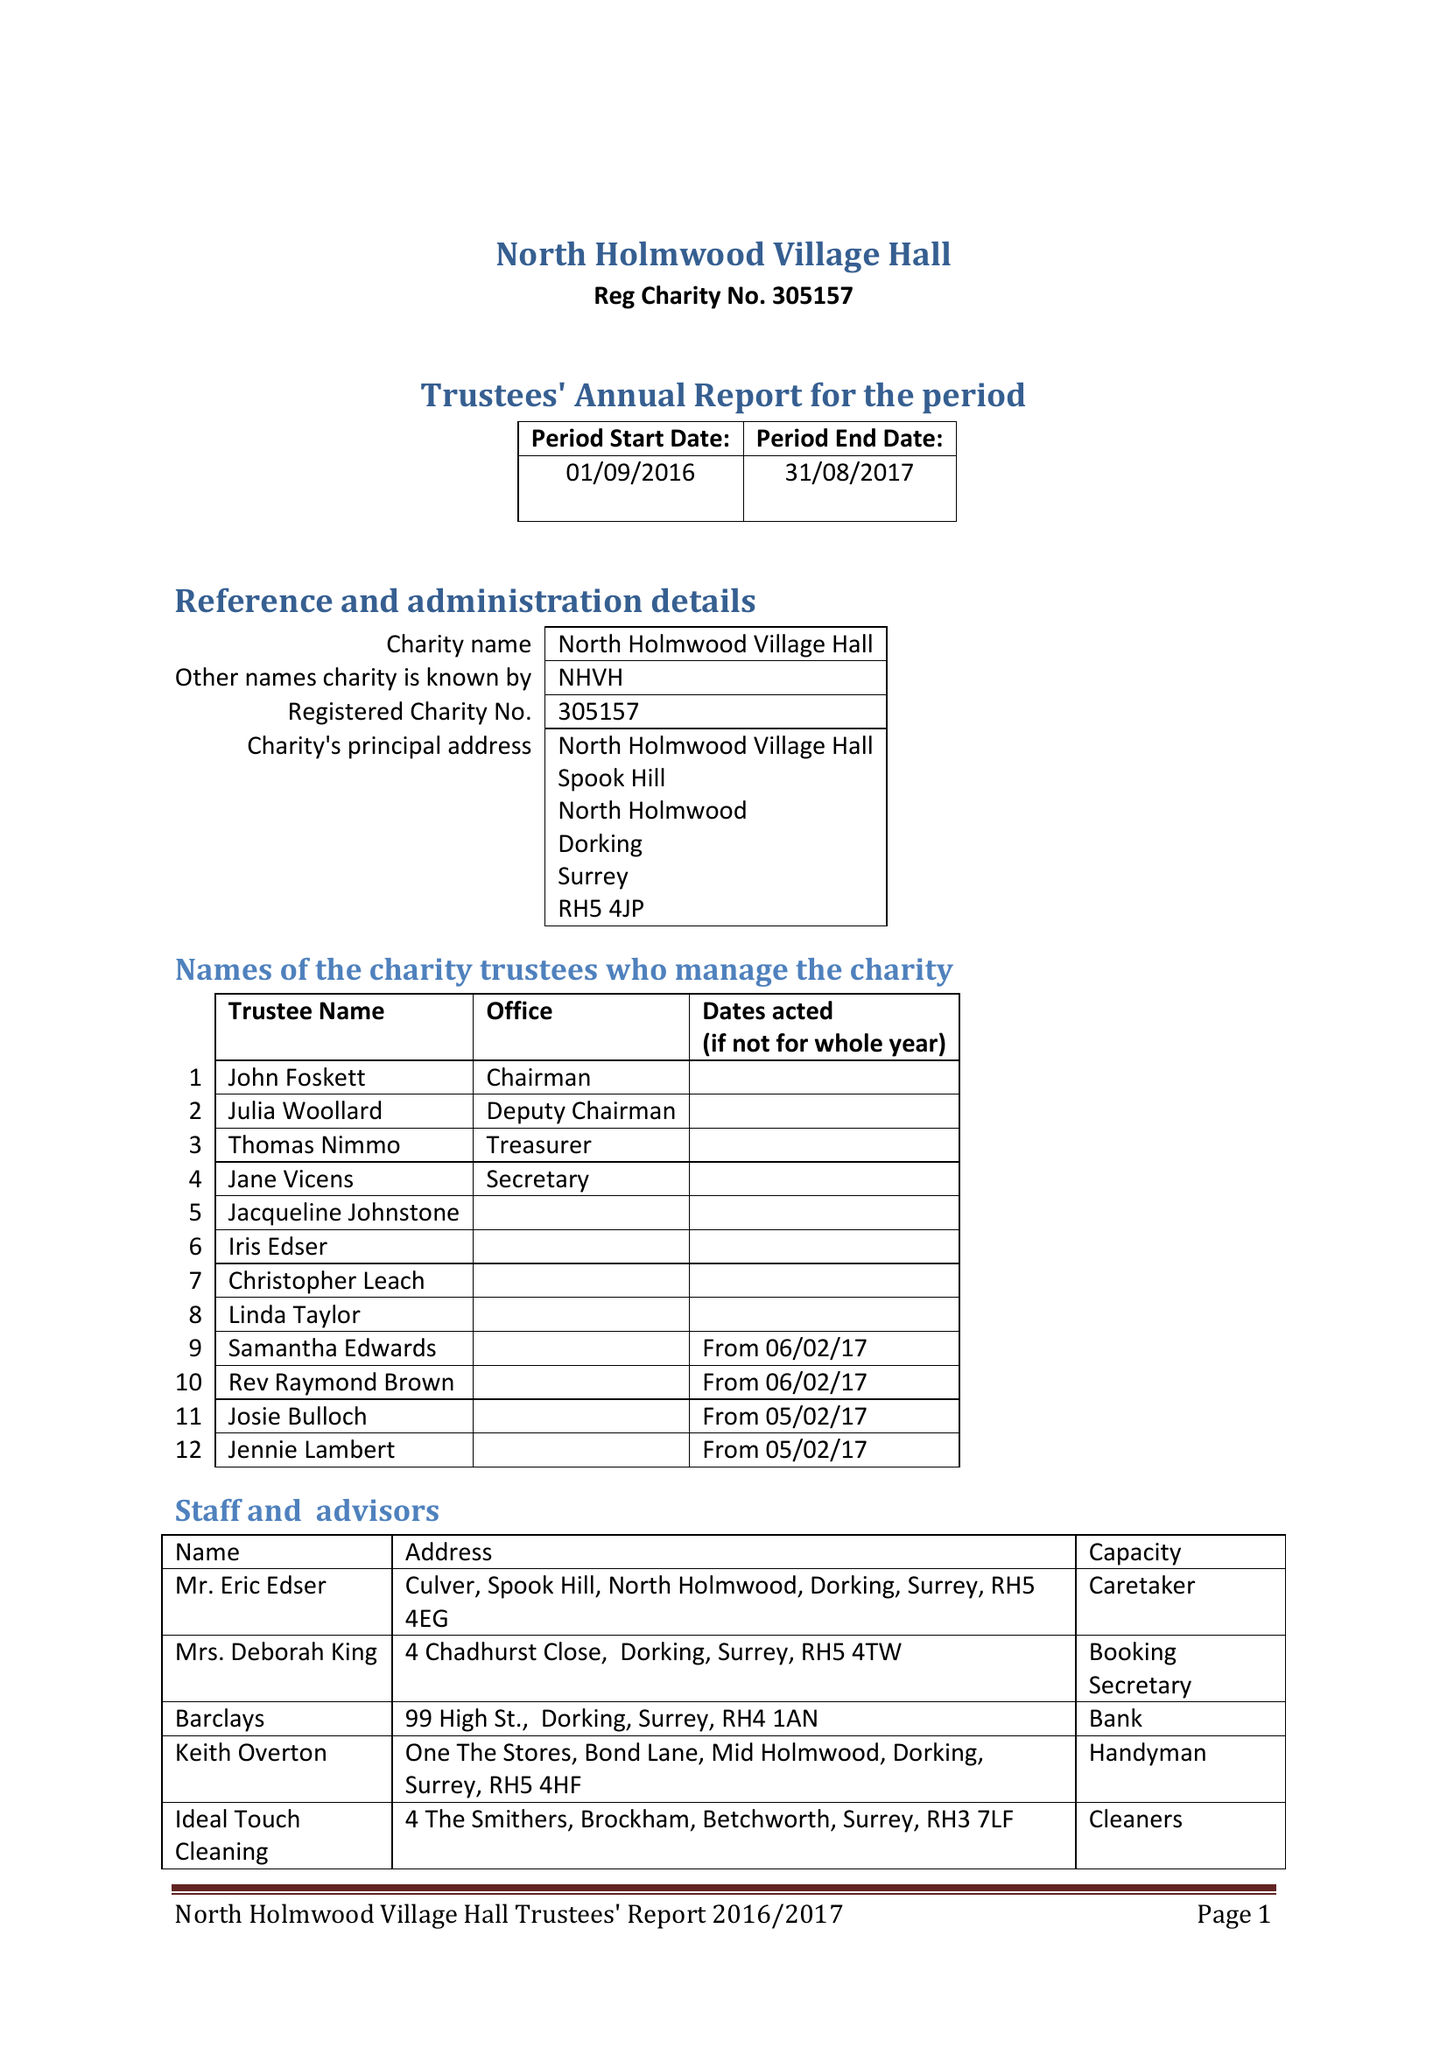What is the value for the charity_number?
Answer the question using a single word or phrase. 305157 